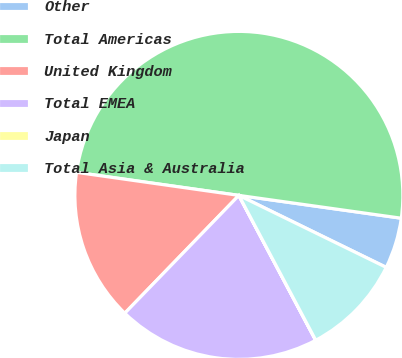Convert chart. <chart><loc_0><loc_0><loc_500><loc_500><pie_chart><fcel>Other<fcel>Total Americas<fcel>United Kingdom<fcel>Total EMEA<fcel>Japan<fcel>Total Asia & Australia<nl><fcel>5.01%<fcel>49.98%<fcel>15.0%<fcel>20.0%<fcel>0.01%<fcel>10.0%<nl></chart> 